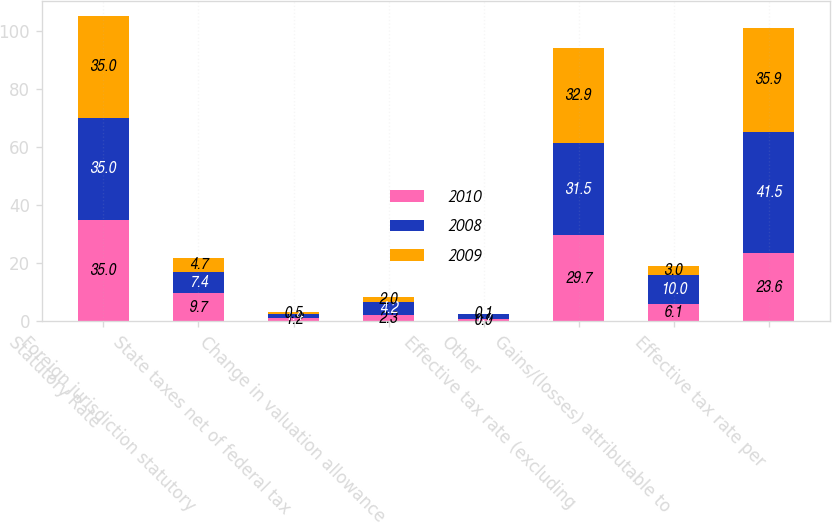Convert chart. <chart><loc_0><loc_0><loc_500><loc_500><stacked_bar_chart><ecel><fcel>Statutory Rate<fcel>Foreign jurisdiction statutory<fcel>State taxes net of federal tax<fcel>Change in valuation allowance<fcel>Other<fcel>Effective tax rate (excluding<fcel>Gains/(losses) attributable to<fcel>Effective tax rate per<nl><fcel>2010<fcel>35<fcel>9.7<fcel>1.2<fcel>2.3<fcel>0.9<fcel>29.7<fcel>6.1<fcel>23.6<nl><fcel>2008<fcel>35<fcel>7.4<fcel>1.4<fcel>4.2<fcel>1.7<fcel>31.5<fcel>10<fcel>41.5<nl><fcel>2009<fcel>35<fcel>4.7<fcel>0.5<fcel>2<fcel>0.1<fcel>32.9<fcel>3<fcel>35.9<nl></chart> 